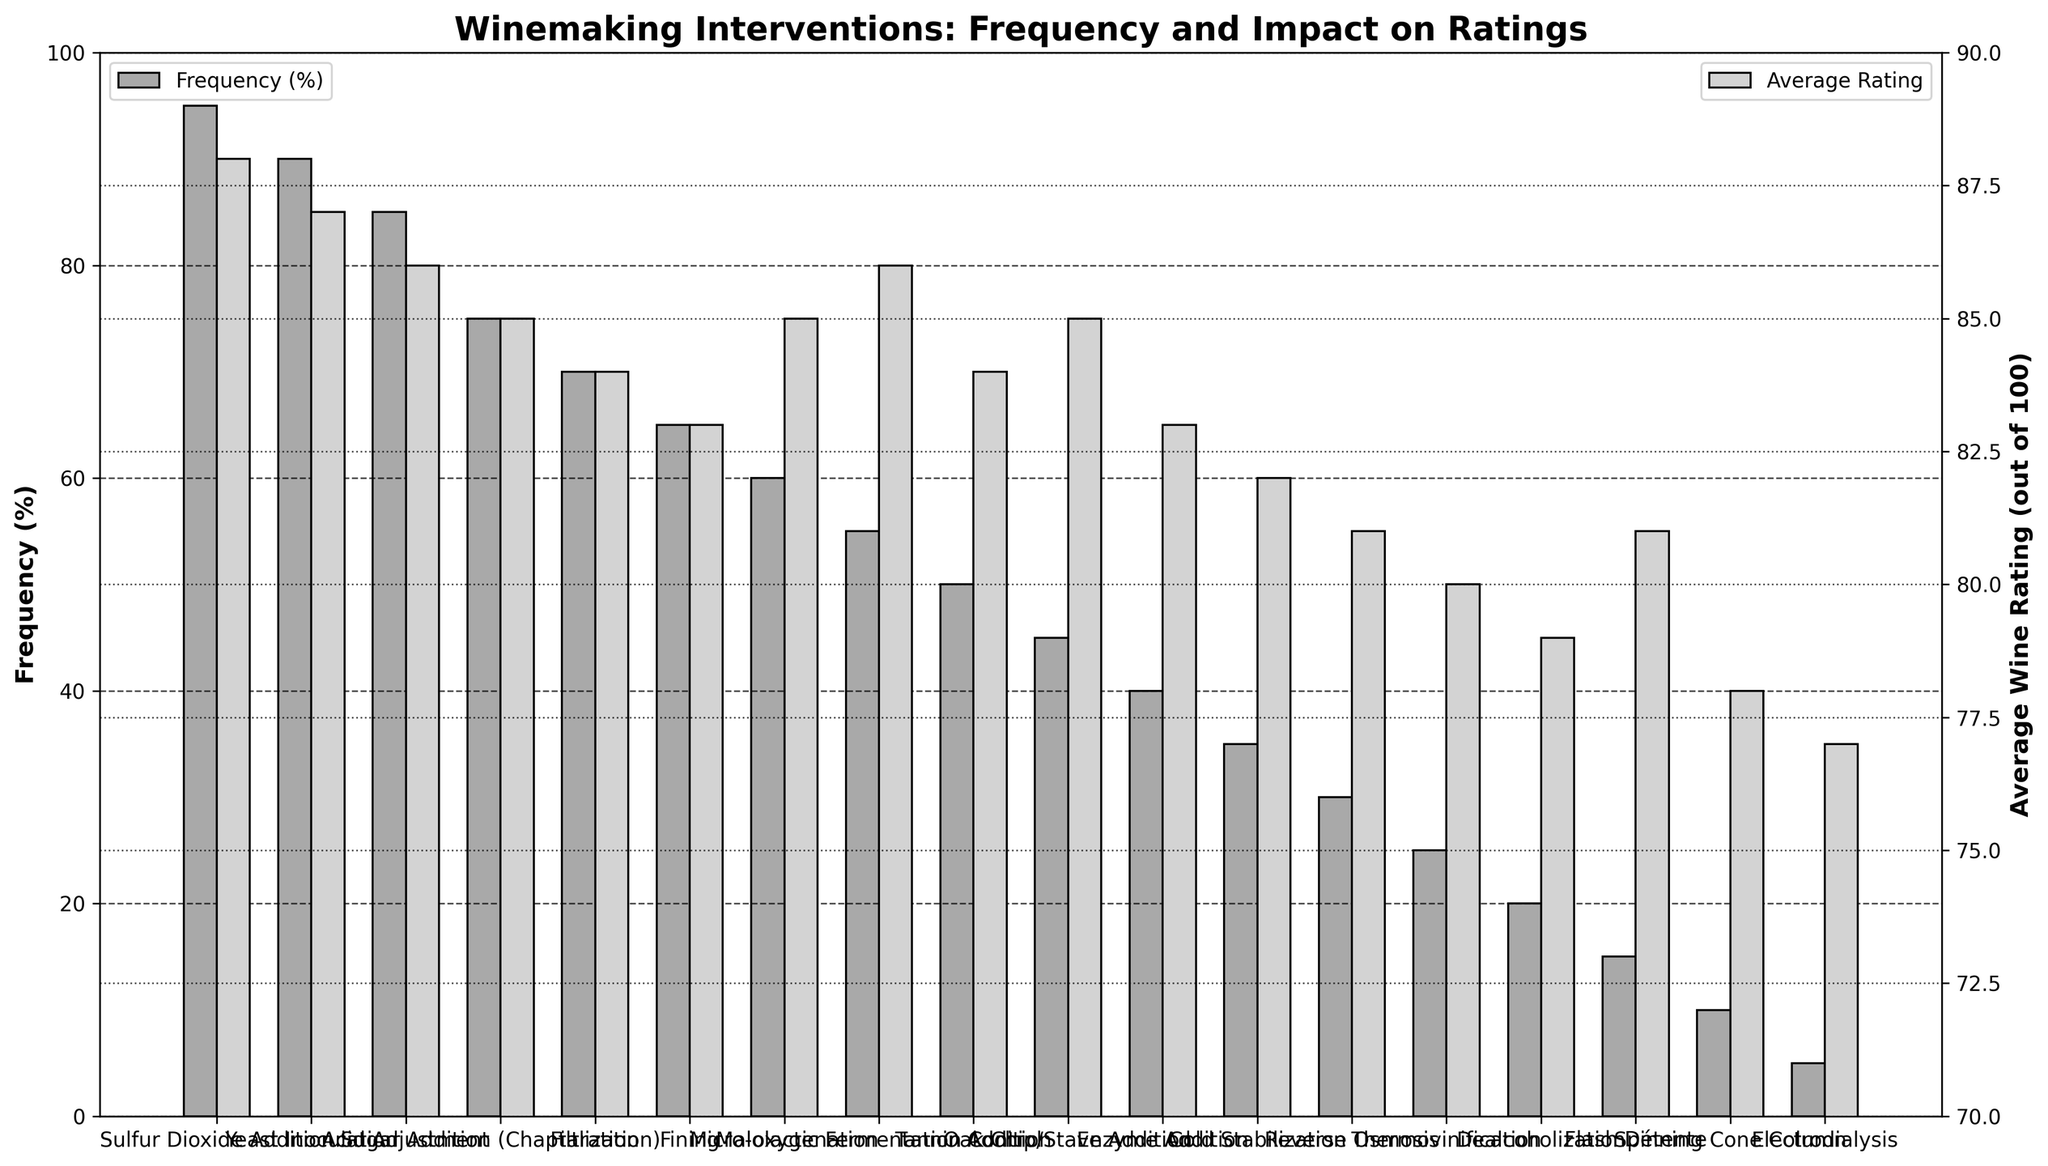Which intervention has the highest frequency? The bar representing Sulfur Dioxide Addition reaches the highest point on the Frequency (%) axis.
Answer: Sulfur Dioxide Addition Which intervention is the least common? The bar for Electrodialysis is the shortest on the Frequency (%) axis.
Answer: Electrodialysis What is the average wine rating for Malolactic Fermentation Control? By looking directly at the Average Wine Rating (out of 100) axis, the bar for Malolactic Fermentation Control reaches 86.
Answer: 86 Which intervention has the highest average wine rating? The tallest bar on the Average Wine Rating (out of 100) axis indicates Sulfur Dioxide Addition with a rating of 88.
Answer: Sulfur Dioxide Addition Compare the average wine ratings for Yeast Inoculation and Sugar Addition (Chaptalization). Which is higher? By comparing their heights on the Average Wine Rating (out of 100) axis, Yeast Inoculation (87) is higher than Sugar Addition (Chaptalization) (85).
Answer: Yeast Inoculation How much higher is the frequency of Acid Adjustment compared to Filtration? The height difference between the bars on the Frequency (%) axis is 85 (Acid Adjustment) - 70 (Filtration) = 15.
Answer: 15 What is the sum of the frequencies for Cold Stabilization and Reverse Osmosis? Adding the heights of their bars on the Frequency (%) axis gives 35 (Cold Stabilization) + 30 (Reverse Osmosis) = 65.
Answer: 65 Which intervention with an average wine rating of 85 is least frequent? Out of the interventions with a rating of 85, the shortest bars on the Frequency (%) axis belong to Oak Chip/Stave Addition (45) and Micro-oxygenation (60). Oak Chip/Stave Addition is the least frequent.
Answer: Oak Chip/Stave Addition Is the average wine rating of dealcoholization higher than electrodialysis? Comparing their bars on the Average Wine Rating (out of 100) axis, Dealcoholization (79) is higher than Electrodialysis (77).
Answer: Yes What is the difference between the highest and lowest average wine ratings shown? The difference between the highest rating (88, Sulfur Dioxide Addition) and the lowest rating (78, Spinning Cone Column) is 88 - 78 = 10.
Answer: 10 